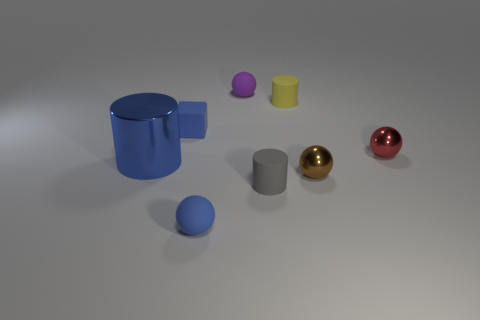Subtract all brown shiny balls. How many balls are left? 3 Subtract all blue cylinders. How many cylinders are left? 2 Subtract all cylinders. How many objects are left? 5 Subtract 1 cylinders. How many cylinders are left? 2 Subtract all cyan cylinders. Subtract all purple spheres. How many cylinders are left? 3 Subtract all green cylinders. How many purple balls are left? 1 Subtract all yellow cylinders. Subtract all big brown objects. How many objects are left? 7 Add 8 large blue objects. How many large blue objects are left? 9 Add 1 tiny shiny spheres. How many tiny shiny spheres exist? 3 Add 2 large blue shiny cylinders. How many objects exist? 10 